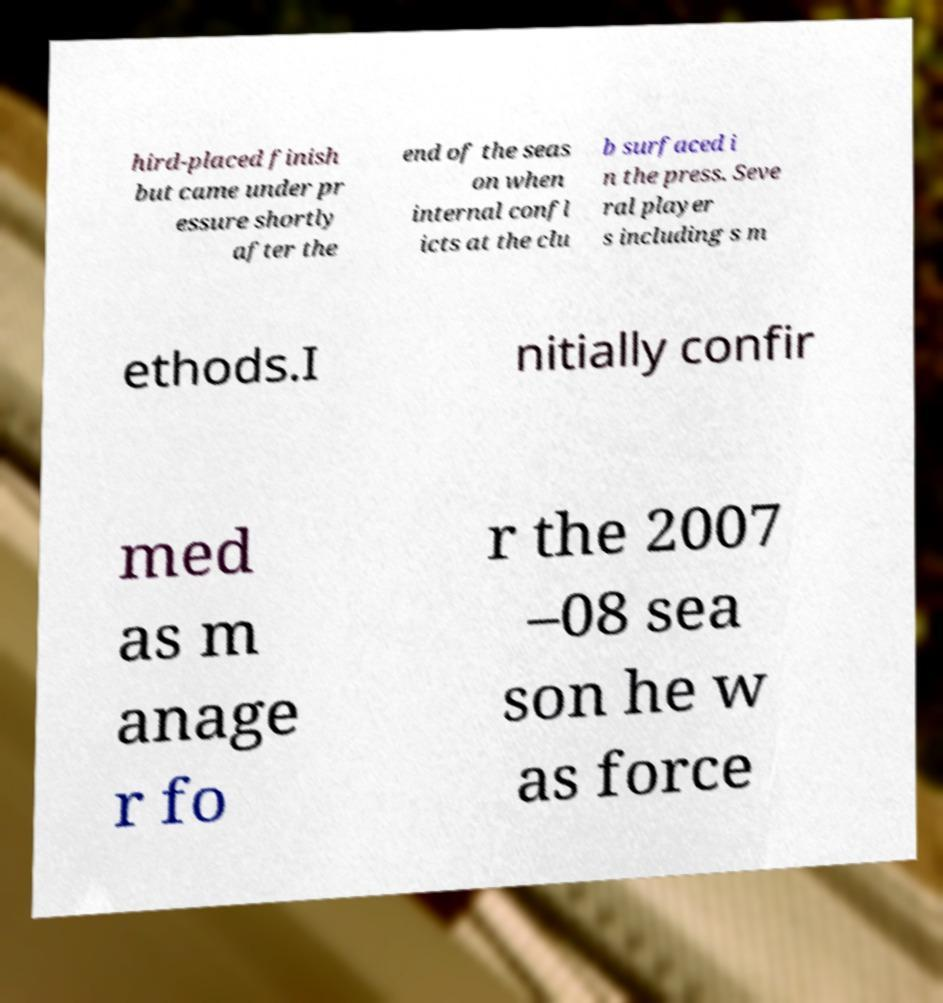Can you read and provide the text displayed in the image?This photo seems to have some interesting text. Can you extract and type it out for me? hird-placed finish but came under pr essure shortly after the end of the seas on when internal confl icts at the clu b surfaced i n the press. Seve ral player s including s m ethods.I nitially confir med as m anage r fo r the 2007 –08 sea son he w as force 